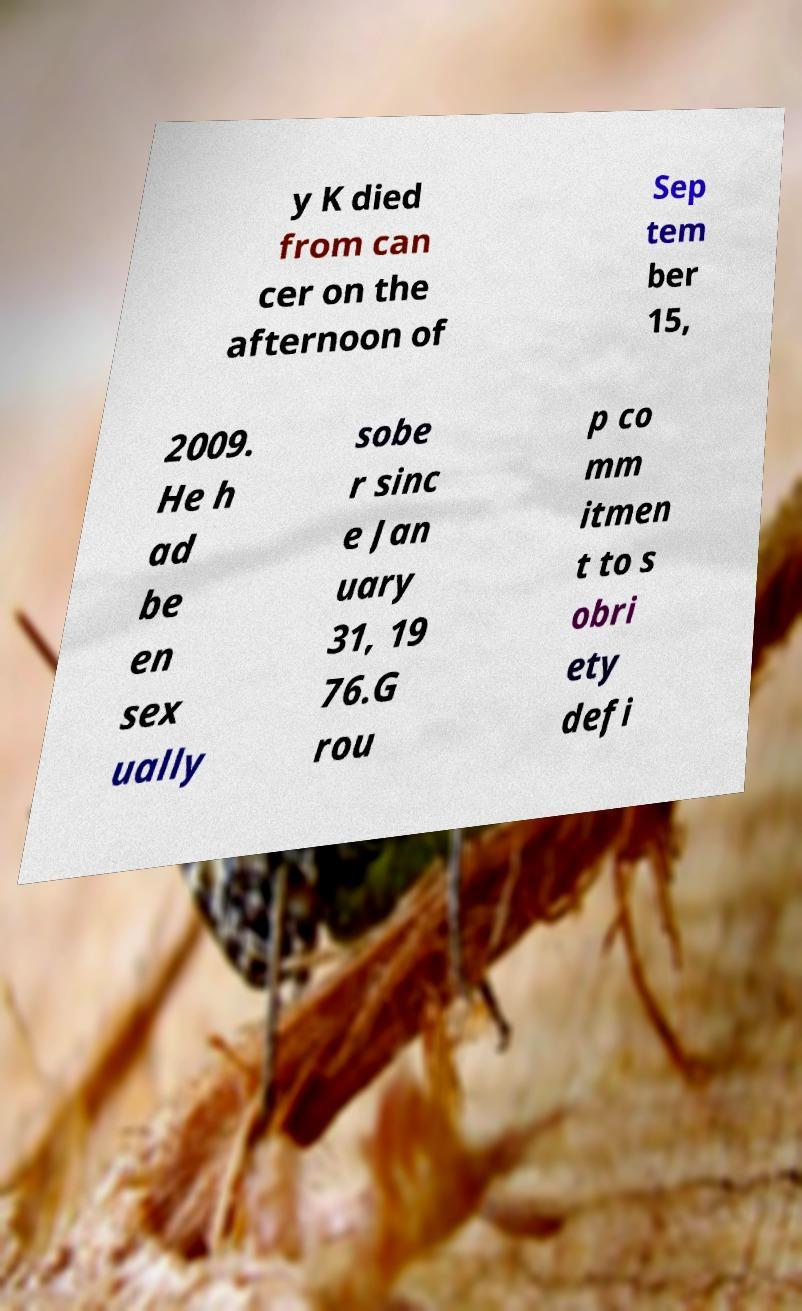What messages or text are displayed in this image? I need them in a readable, typed format. y K died from can cer on the afternoon of Sep tem ber 15, 2009. He h ad be en sex ually sobe r sinc e Jan uary 31, 19 76.G rou p co mm itmen t to s obri ety defi 